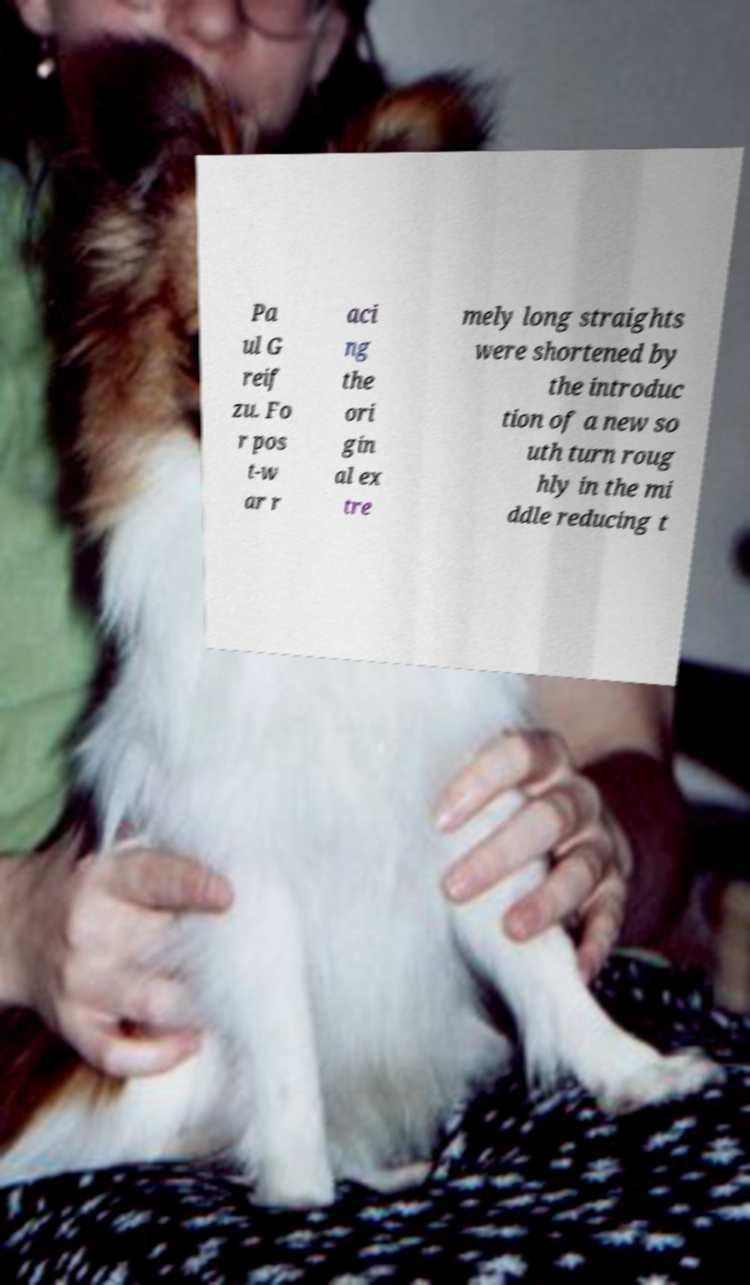Could you assist in decoding the text presented in this image and type it out clearly? Pa ul G reif zu. Fo r pos t-w ar r aci ng the ori gin al ex tre mely long straights were shortened by the introduc tion of a new so uth turn roug hly in the mi ddle reducing t 